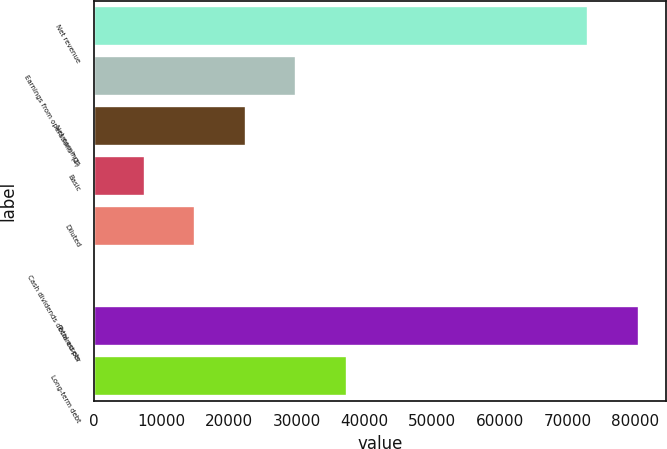Convert chart to OTSL. <chart><loc_0><loc_0><loc_500><loc_500><bar_chart><fcel>Net revenue<fcel>Earnings from operations^(1)<fcel>Net earnings<fcel>Basic<fcel>Diluted<fcel>Cash dividends declared per<fcel>Total assets<fcel>Long-term debt<nl><fcel>73061<fcel>29886.6<fcel>22415<fcel>7471.89<fcel>14943.5<fcel>0.32<fcel>80532.6<fcel>37358.2<nl></chart> 